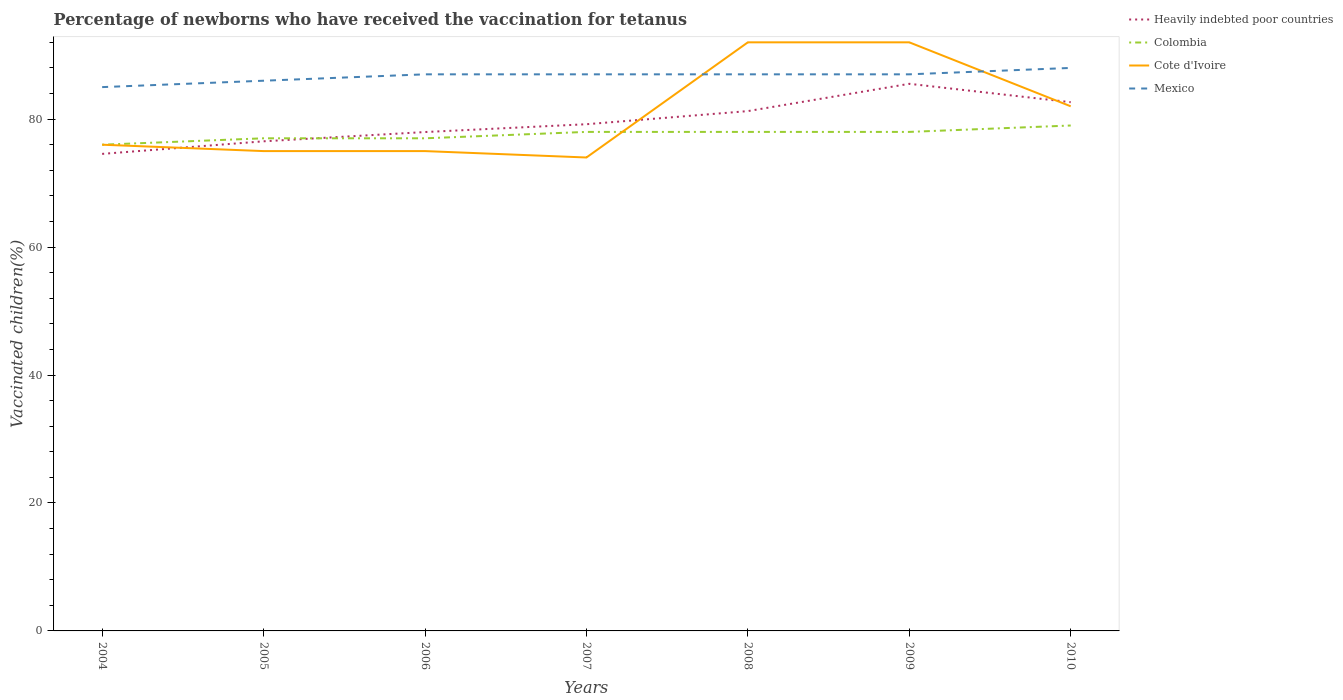How many different coloured lines are there?
Make the answer very short. 4. Across all years, what is the maximum percentage of vaccinated children in Colombia?
Your response must be concise. 76. What is the total percentage of vaccinated children in Cote d'Ivoire in the graph?
Give a very brief answer. 0. What is the difference between the highest and the second highest percentage of vaccinated children in Mexico?
Your answer should be very brief. 3. How many lines are there?
Offer a very short reply. 4. How many years are there in the graph?
Your answer should be compact. 7. Are the values on the major ticks of Y-axis written in scientific E-notation?
Your answer should be very brief. No. Does the graph contain any zero values?
Keep it short and to the point. No. Does the graph contain grids?
Give a very brief answer. No. What is the title of the graph?
Your answer should be very brief. Percentage of newborns who have received the vaccination for tetanus. What is the label or title of the Y-axis?
Offer a very short reply. Vaccinated children(%). What is the Vaccinated children(%) in Heavily indebted poor countries in 2004?
Your answer should be compact. 74.56. What is the Vaccinated children(%) of Colombia in 2004?
Your response must be concise. 76. What is the Vaccinated children(%) of Cote d'Ivoire in 2004?
Offer a terse response. 76. What is the Vaccinated children(%) of Mexico in 2004?
Give a very brief answer. 85. What is the Vaccinated children(%) in Heavily indebted poor countries in 2005?
Ensure brevity in your answer.  76.53. What is the Vaccinated children(%) of Colombia in 2005?
Offer a very short reply. 77. What is the Vaccinated children(%) in Heavily indebted poor countries in 2006?
Keep it short and to the point. 77.98. What is the Vaccinated children(%) of Colombia in 2006?
Your response must be concise. 77. What is the Vaccinated children(%) in Cote d'Ivoire in 2006?
Ensure brevity in your answer.  75. What is the Vaccinated children(%) of Mexico in 2006?
Your answer should be very brief. 87. What is the Vaccinated children(%) in Heavily indebted poor countries in 2007?
Ensure brevity in your answer.  79.2. What is the Vaccinated children(%) of Cote d'Ivoire in 2007?
Provide a short and direct response. 74. What is the Vaccinated children(%) of Heavily indebted poor countries in 2008?
Your response must be concise. 81.25. What is the Vaccinated children(%) in Cote d'Ivoire in 2008?
Your response must be concise. 92. What is the Vaccinated children(%) in Heavily indebted poor countries in 2009?
Ensure brevity in your answer.  85.52. What is the Vaccinated children(%) of Cote d'Ivoire in 2009?
Offer a terse response. 92. What is the Vaccinated children(%) of Mexico in 2009?
Your answer should be compact. 87. What is the Vaccinated children(%) in Heavily indebted poor countries in 2010?
Your answer should be compact. 82.64. What is the Vaccinated children(%) of Colombia in 2010?
Make the answer very short. 79. What is the Vaccinated children(%) of Mexico in 2010?
Your answer should be compact. 88. Across all years, what is the maximum Vaccinated children(%) in Heavily indebted poor countries?
Provide a short and direct response. 85.52. Across all years, what is the maximum Vaccinated children(%) of Colombia?
Your answer should be very brief. 79. Across all years, what is the maximum Vaccinated children(%) of Cote d'Ivoire?
Offer a very short reply. 92. Across all years, what is the minimum Vaccinated children(%) of Heavily indebted poor countries?
Provide a short and direct response. 74.56. What is the total Vaccinated children(%) in Heavily indebted poor countries in the graph?
Keep it short and to the point. 557.68. What is the total Vaccinated children(%) of Colombia in the graph?
Make the answer very short. 543. What is the total Vaccinated children(%) of Cote d'Ivoire in the graph?
Offer a very short reply. 566. What is the total Vaccinated children(%) of Mexico in the graph?
Offer a terse response. 607. What is the difference between the Vaccinated children(%) in Heavily indebted poor countries in 2004 and that in 2005?
Your response must be concise. -1.97. What is the difference between the Vaccinated children(%) in Heavily indebted poor countries in 2004 and that in 2006?
Ensure brevity in your answer.  -3.42. What is the difference between the Vaccinated children(%) of Cote d'Ivoire in 2004 and that in 2006?
Your response must be concise. 1. What is the difference between the Vaccinated children(%) of Mexico in 2004 and that in 2006?
Your answer should be compact. -2. What is the difference between the Vaccinated children(%) in Heavily indebted poor countries in 2004 and that in 2007?
Your answer should be very brief. -4.64. What is the difference between the Vaccinated children(%) of Heavily indebted poor countries in 2004 and that in 2008?
Provide a succinct answer. -6.69. What is the difference between the Vaccinated children(%) of Cote d'Ivoire in 2004 and that in 2008?
Give a very brief answer. -16. What is the difference between the Vaccinated children(%) in Mexico in 2004 and that in 2008?
Keep it short and to the point. -2. What is the difference between the Vaccinated children(%) in Heavily indebted poor countries in 2004 and that in 2009?
Offer a very short reply. -10.96. What is the difference between the Vaccinated children(%) of Cote d'Ivoire in 2004 and that in 2009?
Offer a terse response. -16. What is the difference between the Vaccinated children(%) of Mexico in 2004 and that in 2009?
Ensure brevity in your answer.  -2. What is the difference between the Vaccinated children(%) of Heavily indebted poor countries in 2004 and that in 2010?
Keep it short and to the point. -8.08. What is the difference between the Vaccinated children(%) in Heavily indebted poor countries in 2005 and that in 2006?
Your answer should be compact. -1.45. What is the difference between the Vaccinated children(%) in Cote d'Ivoire in 2005 and that in 2006?
Your response must be concise. 0. What is the difference between the Vaccinated children(%) of Heavily indebted poor countries in 2005 and that in 2007?
Provide a succinct answer. -2.67. What is the difference between the Vaccinated children(%) of Cote d'Ivoire in 2005 and that in 2007?
Keep it short and to the point. 1. What is the difference between the Vaccinated children(%) in Mexico in 2005 and that in 2007?
Provide a short and direct response. -1. What is the difference between the Vaccinated children(%) of Heavily indebted poor countries in 2005 and that in 2008?
Your response must be concise. -4.72. What is the difference between the Vaccinated children(%) of Colombia in 2005 and that in 2008?
Provide a short and direct response. -1. What is the difference between the Vaccinated children(%) in Cote d'Ivoire in 2005 and that in 2008?
Your answer should be compact. -17. What is the difference between the Vaccinated children(%) of Heavily indebted poor countries in 2005 and that in 2009?
Make the answer very short. -8.99. What is the difference between the Vaccinated children(%) in Cote d'Ivoire in 2005 and that in 2009?
Provide a short and direct response. -17. What is the difference between the Vaccinated children(%) in Mexico in 2005 and that in 2009?
Keep it short and to the point. -1. What is the difference between the Vaccinated children(%) of Heavily indebted poor countries in 2005 and that in 2010?
Ensure brevity in your answer.  -6.11. What is the difference between the Vaccinated children(%) of Cote d'Ivoire in 2005 and that in 2010?
Provide a short and direct response. -7. What is the difference between the Vaccinated children(%) of Heavily indebted poor countries in 2006 and that in 2007?
Offer a terse response. -1.22. What is the difference between the Vaccinated children(%) of Cote d'Ivoire in 2006 and that in 2007?
Give a very brief answer. 1. What is the difference between the Vaccinated children(%) in Heavily indebted poor countries in 2006 and that in 2008?
Give a very brief answer. -3.27. What is the difference between the Vaccinated children(%) in Colombia in 2006 and that in 2008?
Provide a succinct answer. -1. What is the difference between the Vaccinated children(%) in Heavily indebted poor countries in 2006 and that in 2009?
Your answer should be compact. -7.54. What is the difference between the Vaccinated children(%) of Colombia in 2006 and that in 2009?
Make the answer very short. -1. What is the difference between the Vaccinated children(%) of Cote d'Ivoire in 2006 and that in 2009?
Your answer should be compact. -17. What is the difference between the Vaccinated children(%) of Mexico in 2006 and that in 2009?
Provide a succinct answer. 0. What is the difference between the Vaccinated children(%) of Heavily indebted poor countries in 2006 and that in 2010?
Your answer should be very brief. -4.67. What is the difference between the Vaccinated children(%) in Colombia in 2006 and that in 2010?
Your response must be concise. -2. What is the difference between the Vaccinated children(%) in Cote d'Ivoire in 2006 and that in 2010?
Provide a succinct answer. -7. What is the difference between the Vaccinated children(%) in Heavily indebted poor countries in 2007 and that in 2008?
Give a very brief answer. -2.05. What is the difference between the Vaccinated children(%) in Mexico in 2007 and that in 2008?
Offer a terse response. 0. What is the difference between the Vaccinated children(%) of Heavily indebted poor countries in 2007 and that in 2009?
Offer a terse response. -6.32. What is the difference between the Vaccinated children(%) of Cote d'Ivoire in 2007 and that in 2009?
Make the answer very short. -18. What is the difference between the Vaccinated children(%) of Mexico in 2007 and that in 2009?
Give a very brief answer. 0. What is the difference between the Vaccinated children(%) in Heavily indebted poor countries in 2007 and that in 2010?
Offer a very short reply. -3.44. What is the difference between the Vaccinated children(%) in Mexico in 2007 and that in 2010?
Offer a terse response. -1. What is the difference between the Vaccinated children(%) of Heavily indebted poor countries in 2008 and that in 2009?
Offer a terse response. -4.27. What is the difference between the Vaccinated children(%) in Colombia in 2008 and that in 2009?
Your response must be concise. 0. What is the difference between the Vaccinated children(%) of Heavily indebted poor countries in 2008 and that in 2010?
Keep it short and to the point. -1.39. What is the difference between the Vaccinated children(%) in Colombia in 2008 and that in 2010?
Give a very brief answer. -1. What is the difference between the Vaccinated children(%) of Heavily indebted poor countries in 2009 and that in 2010?
Your response must be concise. 2.87. What is the difference between the Vaccinated children(%) in Cote d'Ivoire in 2009 and that in 2010?
Keep it short and to the point. 10. What is the difference between the Vaccinated children(%) of Mexico in 2009 and that in 2010?
Keep it short and to the point. -1. What is the difference between the Vaccinated children(%) in Heavily indebted poor countries in 2004 and the Vaccinated children(%) in Colombia in 2005?
Ensure brevity in your answer.  -2.44. What is the difference between the Vaccinated children(%) of Heavily indebted poor countries in 2004 and the Vaccinated children(%) of Cote d'Ivoire in 2005?
Provide a short and direct response. -0.44. What is the difference between the Vaccinated children(%) in Heavily indebted poor countries in 2004 and the Vaccinated children(%) in Mexico in 2005?
Provide a succinct answer. -11.44. What is the difference between the Vaccinated children(%) in Cote d'Ivoire in 2004 and the Vaccinated children(%) in Mexico in 2005?
Keep it short and to the point. -10. What is the difference between the Vaccinated children(%) of Heavily indebted poor countries in 2004 and the Vaccinated children(%) of Colombia in 2006?
Keep it short and to the point. -2.44. What is the difference between the Vaccinated children(%) in Heavily indebted poor countries in 2004 and the Vaccinated children(%) in Cote d'Ivoire in 2006?
Give a very brief answer. -0.44. What is the difference between the Vaccinated children(%) in Heavily indebted poor countries in 2004 and the Vaccinated children(%) in Mexico in 2006?
Your response must be concise. -12.44. What is the difference between the Vaccinated children(%) in Colombia in 2004 and the Vaccinated children(%) in Mexico in 2006?
Your response must be concise. -11. What is the difference between the Vaccinated children(%) in Cote d'Ivoire in 2004 and the Vaccinated children(%) in Mexico in 2006?
Keep it short and to the point. -11. What is the difference between the Vaccinated children(%) in Heavily indebted poor countries in 2004 and the Vaccinated children(%) in Colombia in 2007?
Your answer should be compact. -3.44. What is the difference between the Vaccinated children(%) of Heavily indebted poor countries in 2004 and the Vaccinated children(%) of Cote d'Ivoire in 2007?
Your answer should be compact. 0.56. What is the difference between the Vaccinated children(%) in Heavily indebted poor countries in 2004 and the Vaccinated children(%) in Mexico in 2007?
Your response must be concise. -12.44. What is the difference between the Vaccinated children(%) in Colombia in 2004 and the Vaccinated children(%) in Mexico in 2007?
Your response must be concise. -11. What is the difference between the Vaccinated children(%) of Heavily indebted poor countries in 2004 and the Vaccinated children(%) of Colombia in 2008?
Your answer should be compact. -3.44. What is the difference between the Vaccinated children(%) in Heavily indebted poor countries in 2004 and the Vaccinated children(%) in Cote d'Ivoire in 2008?
Offer a terse response. -17.44. What is the difference between the Vaccinated children(%) in Heavily indebted poor countries in 2004 and the Vaccinated children(%) in Mexico in 2008?
Give a very brief answer. -12.44. What is the difference between the Vaccinated children(%) of Colombia in 2004 and the Vaccinated children(%) of Cote d'Ivoire in 2008?
Keep it short and to the point. -16. What is the difference between the Vaccinated children(%) in Colombia in 2004 and the Vaccinated children(%) in Mexico in 2008?
Offer a very short reply. -11. What is the difference between the Vaccinated children(%) of Heavily indebted poor countries in 2004 and the Vaccinated children(%) of Colombia in 2009?
Offer a very short reply. -3.44. What is the difference between the Vaccinated children(%) of Heavily indebted poor countries in 2004 and the Vaccinated children(%) of Cote d'Ivoire in 2009?
Your answer should be very brief. -17.44. What is the difference between the Vaccinated children(%) in Heavily indebted poor countries in 2004 and the Vaccinated children(%) in Mexico in 2009?
Give a very brief answer. -12.44. What is the difference between the Vaccinated children(%) of Colombia in 2004 and the Vaccinated children(%) of Mexico in 2009?
Give a very brief answer. -11. What is the difference between the Vaccinated children(%) of Heavily indebted poor countries in 2004 and the Vaccinated children(%) of Colombia in 2010?
Keep it short and to the point. -4.44. What is the difference between the Vaccinated children(%) of Heavily indebted poor countries in 2004 and the Vaccinated children(%) of Cote d'Ivoire in 2010?
Your answer should be very brief. -7.44. What is the difference between the Vaccinated children(%) of Heavily indebted poor countries in 2004 and the Vaccinated children(%) of Mexico in 2010?
Your response must be concise. -13.44. What is the difference between the Vaccinated children(%) of Colombia in 2004 and the Vaccinated children(%) of Mexico in 2010?
Ensure brevity in your answer.  -12. What is the difference between the Vaccinated children(%) of Cote d'Ivoire in 2004 and the Vaccinated children(%) of Mexico in 2010?
Your answer should be very brief. -12. What is the difference between the Vaccinated children(%) of Heavily indebted poor countries in 2005 and the Vaccinated children(%) of Colombia in 2006?
Give a very brief answer. -0.47. What is the difference between the Vaccinated children(%) of Heavily indebted poor countries in 2005 and the Vaccinated children(%) of Cote d'Ivoire in 2006?
Offer a terse response. 1.53. What is the difference between the Vaccinated children(%) in Heavily indebted poor countries in 2005 and the Vaccinated children(%) in Mexico in 2006?
Ensure brevity in your answer.  -10.47. What is the difference between the Vaccinated children(%) of Colombia in 2005 and the Vaccinated children(%) of Cote d'Ivoire in 2006?
Make the answer very short. 2. What is the difference between the Vaccinated children(%) of Colombia in 2005 and the Vaccinated children(%) of Mexico in 2006?
Your response must be concise. -10. What is the difference between the Vaccinated children(%) in Heavily indebted poor countries in 2005 and the Vaccinated children(%) in Colombia in 2007?
Make the answer very short. -1.47. What is the difference between the Vaccinated children(%) of Heavily indebted poor countries in 2005 and the Vaccinated children(%) of Cote d'Ivoire in 2007?
Your answer should be very brief. 2.53. What is the difference between the Vaccinated children(%) in Heavily indebted poor countries in 2005 and the Vaccinated children(%) in Mexico in 2007?
Make the answer very short. -10.47. What is the difference between the Vaccinated children(%) of Heavily indebted poor countries in 2005 and the Vaccinated children(%) of Colombia in 2008?
Your answer should be compact. -1.47. What is the difference between the Vaccinated children(%) of Heavily indebted poor countries in 2005 and the Vaccinated children(%) of Cote d'Ivoire in 2008?
Keep it short and to the point. -15.47. What is the difference between the Vaccinated children(%) in Heavily indebted poor countries in 2005 and the Vaccinated children(%) in Mexico in 2008?
Make the answer very short. -10.47. What is the difference between the Vaccinated children(%) in Colombia in 2005 and the Vaccinated children(%) in Mexico in 2008?
Offer a terse response. -10. What is the difference between the Vaccinated children(%) in Cote d'Ivoire in 2005 and the Vaccinated children(%) in Mexico in 2008?
Provide a succinct answer. -12. What is the difference between the Vaccinated children(%) in Heavily indebted poor countries in 2005 and the Vaccinated children(%) in Colombia in 2009?
Ensure brevity in your answer.  -1.47. What is the difference between the Vaccinated children(%) in Heavily indebted poor countries in 2005 and the Vaccinated children(%) in Cote d'Ivoire in 2009?
Your answer should be compact. -15.47. What is the difference between the Vaccinated children(%) in Heavily indebted poor countries in 2005 and the Vaccinated children(%) in Mexico in 2009?
Make the answer very short. -10.47. What is the difference between the Vaccinated children(%) of Colombia in 2005 and the Vaccinated children(%) of Cote d'Ivoire in 2009?
Give a very brief answer. -15. What is the difference between the Vaccinated children(%) in Heavily indebted poor countries in 2005 and the Vaccinated children(%) in Colombia in 2010?
Provide a short and direct response. -2.47. What is the difference between the Vaccinated children(%) of Heavily indebted poor countries in 2005 and the Vaccinated children(%) of Cote d'Ivoire in 2010?
Ensure brevity in your answer.  -5.47. What is the difference between the Vaccinated children(%) of Heavily indebted poor countries in 2005 and the Vaccinated children(%) of Mexico in 2010?
Your answer should be compact. -11.47. What is the difference between the Vaccinated children(%) of Colombia in 2005 and the Vaccinated children(%) of Mexico in 2010?
Provide a succinct answer. -11. What is the difference between the Vaccinated children(%) of Cote d'Ivoire in 2005 and the Vaccinated children(%) of Mexico in 2010?
Make the answer very short. -13. What is the difference between the Vaccinated children(%) of Heavily indebted poor countries in 2006 and the Vaccinated children(%) of Colombia in 2007?
Provide a short and direct response. -0.02. What is the difference between the Vaccinated children(%) in Heavily indebted poor countries in 2006 and the Vaccinated children(%) in Cote d'Ivoire in 2007?
Your answer should be compact. 3.98. What is the difference between the Vaccinated children(%) of Heavily indebted poor countries in 2006 and the Vaccinated children(%) of Mexico in 2007?
Your answer should be very brief. -9.02. What is the difference between the Vaccinated children(%) of Cote d'Ivoire in 2006 and the Vaccinated children(%) of Mexico in 2007?
Keep it short and to the point. -12. What is the difference between the Vaccinated children(%) of Heavily indebted poor countries in 2006 and the Vaccinated children(%) of Colombia in 2008?
Keep it short and to the point. -0.02. What is the difference between the Vaccinated children(%) in Heavily indebted poor countries in 2006 and the Vaccinated children(%) in Cote d'Ivoire in 2008?
Your answer should be very brief. -14.02. What is the difference between the Vaccinated children(%) of Heavily indebted poor countries in 2006 and the Vaccinated children(%) of Mexico in 2008?
Provide a succinct answer. -9.02. What is the difference between the Vaccinated children(%) in Colombia in 2006 and the Vaccinated children(%) in Mexico in 2008?
Make the answer very short. -10. What is the difference between the Vaccinated children(%) of Cote d'Ivoire in 2006 and the Vaccinated children(%) of Mexico in 2008?
Your answer should be compact. -12. What is the difference between the Vaccinated children(%) of Heavily indebted poor countries in 2006 and the Vaccinated children(%) of Colombia in 2009?
Ensure brevity in your answer.  -0.02. What is the difference between the Vaccinated children(%) in Heavily indebted poor countries in 2006 and the Vaccinated children(%) in Cote d'Ivoire in 2009?
Your answer should be compact. -14.02. What is the difference between the Vaccinated children(%) in Heavily indebted poor countries in 2006 and the Vaccinated children(%) in Mexico in 2009?
Offer a terse response. -9.02. What is the difference between the Vaccinated children(%) in Colombia in 2006 and the Vaccinated children(%) in Mexico in 2009?
Make the answer very short. -10. What is the difference between the Vaccinated children(%) in Heavily indebted poor countries in 2006 and the Vaccinated children(%) in Colombia in 2010?
Provide a succinct answer. -1.02. What is the difference between the Vaccinated children(%) in Heavily indebted poor countries in 2006 and the Vaccinated children(%) in Cote d'Ivoire in 2010?
Make the answer very short. -4.02. What is the difference between the Vaccinated children(%) of Heavily indebted poor countries in 2006 and the Vaccinated children(%) of Mexico in 2010?
Offer a terse response. -10.02. What is the difference between the Vaccinated children(%) in Colombia in 2006 and the Vaccinated children(%) in Mexico in 2010?
Ensure brevity in your answer.  -11. What is the difference between the Vaccinated children(%) in Heavily indebted poor countries in 2007 and the Vaccinated children(%) in Colombia in 2008?
Offer a very short reply. 1.2. What is the difference between the Vaccinated children(%) in Heavily indebted poor countries in 2007 and the Vaccinated children(%) in Cote d'Ivoire in 2008?
Offer a very short reply. -12.8. What is the difference between the Vaccinated children(%) of Heavily indebted poor countries in 2007 and the Vaccinated children(%) of Mexico in 2008?
Your answer should be compact. -7.8. What is the difference between the Vaccinated children(%) in Colombia in 2007 and the Vaccinated children(%) in Cote d'Ivoire in 2008?
Provide a succinct answer. -14. What is the difference between the Vaccinated children(%) in Colombia in 2007 and the Vaccinated children(%) in Mexico in 2008?
Offer a very short reply. -9. What is the difference between the Vaccinated children(%) in Heavily indebted poor countries in 2007 and the Vaccinated children(%) in Colombia in 2009?
Offer a terse response. 1.2. What is the difference between the Vaccinated children(%) in Heavily indebted poor countries in 2007 and the Vaccinated children(%) in Cote d'Ivoire in 2009?
Provide a short and direct response. -12.8. What is the difference between the Vaccinated children(%) in Heavily indebted poor countries in 2007 and the Vaccinated children(%) in Mexico in 2009?
Your response must be concise. -7.8. What is the difference between the Vaccinated children(%) of Colombia in 2007 and the Vaccinated children(%) of Cote d'Ivoire in 2009?
Offer a terse response. -14. What is the difference between the Vaccinated children(%) of Heavily indebted poor countries in 2007 and the Vaccinated children(%) of Colombia in 2010?
Your answer should be very brief. 0.2. What is the difference between the Vaccinated children(%) of Heavily indebted poor countries in 2007 and the Vaccinated children(%) of Cote d'Ivoire in 2010?
Offer a very short reply. -2.8. What is the difference between the Vaccinated children(%) of Heavily indebted poor countries in 2007 and the Vaccinated children(%) of Mexico in 2010?
Provide a succinct answer. -8.8. What is the difference between the Vaccinated children(%) of Colombia in 2007 and the Vaccinated children(%) of Mexico in 2010?
Ensure brevity in your answer.  -10. What is the difference between the Vaccinated children(%) in Cote d'Ivoire in 2007 and the Vaccinated children(%) in Mexico in 2010?
Your response must be concise. -14. What is the difference between the Vaccinated children(%) in Heavily indebted poor countries in 2008 and the Vaccinated children(%) in Colombia in 2009?
Your answer should be very brief. 3.25. What is the difference between the Vaccinated children(%) of Heavily indebted poor countries in 2008 and the Vaccinated children(%) of Cote d'Ivoire in 2009?
Give a very brief answer. -10.75. What is the difference between the Vaccinated children(%) of Heavily indebted poor countries in 2008 and the Vaccinated children(%) of Mexico in 2009?
Provide a short and direct response. -5.75. What is the difference between the Vaccinated children(%) in Heavily indebted poor countries in 2008 and the Vaccinated children(%) in Colombia in 2010?
Keep it short and to the point. 2.25. What is the difference between the Vaccinated children(%) of Heavily indebted poor countries in 2008 and the Vaccinated children(%) of Cote d'Ivoire in 2010?
Your answer should be compact. -0.75. What is the difference between the Vaccinated children(%) of Heavily indebted poor countries in 2008 and the Vaccinated children(%) of Mexico in 2010?
Give a very brief answer. -6.75. What is the difference between the Vaccinated children(%) in Colombia in 2008 and the Vaccinated children(%) in Cote d'Ivoire in 2010?
Your response must be concise. -4. What is the difference between the Vaccinated children(%) in Colombia in 2008 and the Vaccinated children(%) in Mexico in 2010?
Your answer should be very brief. -10. What is the difference between the Vaccinated children(%) in Heavily indebted poor countries in 2009 and the Vaccinated children(%) in Colombia in 2010?
Ensure brevity in your answer.  6.52. What is the difference between the Vaccinated children(%) of Heavily indebted poor countries in 2009 and the Vaccinated children(%) of Cote d'Ivoire in 2010?
Provide a succinct answer. 3.52. What is the difference between the Vaccinated children(%) of Heavily indebted poor countries in 2009 and the Vaccinated children(%) of Mexico in 2010?
Provide a succinct answer. -2.48. What is the difference between the Vaccinated children(%) of Colombia in 2009 and the Vaccinated children(%) of Cote d'Ivoire in 2010?
Your response must be concise. -4. What is the average Vaccinated children(%) of Heavily indebted poor countries per year?
Provide a short and direct response. 79.67. What is the average Vaccinated children(%) of Colombia per year?
Your response must be concise. 77.57. What is the average Vaccinated children(%) in Cote d'Ivoire per year?
Make the answer very short. 80.86. What is the average Vaccinated children(%) in Mexico per year?
Offer a very short reply. 86.71. In the year 2004, what is the difference between the Vaccinated children(%) of Heavily indebted poor countries and Vaccinated children(%) of Colombia?
Keep it short and to the point. -1.44. In the year 2004, what is the difference between the Vaccinated children(%) of Heavily indebted poor countries and Vaccinated children(%) of Cote d'Ivoire?
Your answer should be very brief. -1.44. In the year 2004, what is the difference between the Vaccinated children(%) of Heavily indebted poor countries and Vaccinated children(%) of Mexico?
Provide a succinct answer. -10.44. In the year 2004, what is the difference between the Vaccinated children(%) of Cote d'Ivoire and Vaccinated children(%) of Mexico?
Provide a short and direct response. -9. In the year 2005, what is the difference between the Vaccinated children(%) of Heavily indebted poor countries and Vaccinated children(%) of Colombia?
Your answer should be very brief. -0.47. In the year 2005, what is the difference between the Vaccinated children(%) of Heavily indebted poor countries and Vaccinated children(%) of Cote d'Ivoire?
Your answer should be compact. 1.53. In the year 2005, what is the difference between the Vaccinated children(%) in Heavily indebted poor countries and Vaccinated children(%) in Mexico?
Make the answer very short. -9.47. In the year 2005, what is the difference between the Vaccinated children(%) of Cote d'Ivoire and Vaccinated children(%) of Mexico?
Give a very brief answer. -11. In the year 2006, what is the difference between the Vaccinated children(%) in Heavily indebted poor countries and Vaccinated children(%) in Colombia?
Offer a very short reply. 0.98. In the year 2006, what is the difference between the Vaccinated children(%) of Heavily indebted poor countries and Vaccinated children(%) of Cote d'Ivoire?
Ensure brevity in your answer.  2.98. In the year 2006, what is the difference between the Vaccinated children(%) in Heavily indebted poor countries and Vaccinated children(%) in Mexico?
Provide a succinct answer. -9.02. In the year 2006, what is the difference between the Vaccinated children(%) of Colombia and Vaccinated children(%) of Cote d'Ivoire?
Your response must be concise. 2. In the year 2006, what is the difference between the Vaccinated children(%) of Cote d'Ivoire and Vaccinated children(%) of Mexico?
Offer a terse response. -12. In the year 2007, what is the difference between the Vaccinated children(%) of Heavily indebted poor countries and Vaccinated children(%) of Colombia?
Offer a very short reply. 1.2. In the year 2007, what is the difference between the Vaccinated children(%) in Heavily indebted poor countries and Vaccinated children(%) in Cote d'Ivoire?
Your response must be concise. 5.2. In the year 2007, what is the difference between the Vaccinated children(%) in Heavily indebted poor countries and Vaccinated children(%) in Mexico?
Your answer should be very brief. -7.8. In the year 2007, what is the difference between the Vaccinated children(%) in Colombia and Vaccinated children(%) in Cote d'Ivoire?
Provide a succinct answer. 4. In the year 2008, what is the difference between the Vaccinated children(%) of Heavily indebted poor countries and Vaccinated children(%) of Colombia?
Your response must be concise. 3.25. In the year 2008, what is the difference between the Vaccinated children(%) in Heavily indebted poor countries and Vaccinated children(%) in Cote d'Ivoire?
Your answer should be very brief. -10.75. In the year 2008, what is the difference between the Vaccinated children(%) of Heavily indebted poor countries and Vaccinated children(%) of Mexico?
Provide a succinct answer. -5.75. In the year 2009, what is the difference between the Vaccinated children(%) of Heavily indebted poor countries and Vaccinated children(%) of Colombia?
Offer a terse response. 7.52. In the year 2009, what is the difference between the Vaccinated children(%) of Heavily indebted poor countries and Vaccinated children(%) of Cote d'Ivoire?
Your answer should be very brief. -6.48. In the year 2009, what is the difference between the Vaccinated children(%) of Heavily indebted poor countries and Vaccinated children(%) of Mexico?
Offer a very short reply. -1.48. In the year 2009, what is the difference between the Vaccinated children(%) of Colombia and Vaccinated children(%) of Cote d'Ivoire?
Provide a short and direct response. -14. In the year 2009, what is the difference between the Vaccinated children(%) of Colombia and Vaccinated children(%) of Mexico?
Ensure brevity in your answer.  -9. In the year 2009, what is the difference between the Vaccinated children(%) of Cote d'Ivoire and Vaccinated children(%) of Mexico?
Ensure brevity in your answer.  5. In the year 2010, what is the difference between the Vaccinated children(%) of Heavily indebted poor countries and Vaccinated children(%) of Colombia?
Your response must be concise. 3.64. In the year 2010, what is the difference between the Vaccinated children(%) of Heavily indebted poor countries and Vaccinated children(%) of Cote d'Ivoire?
Provide a short and direct response. 0.64. In the year 2010, what is the difference between the Vaccinated children(%) of Heavily indebted poor countries and Vaccinated children(%) of Mexico?
Ensure brevity in your answer.  -5.36. In the year 2010, what is the difference between the Vaccinated children(%) of Cote d'Ivoire and Vaccinated children(%) of Mexico?
Your answer should be compact. -6. What is the ratio of the Vaccinated children(%) of Heavily indebted poor countries in 2004 to that in 2005?
Ensure brevity in your answer.  0.97. What is the ratio of the Vaccinated children(%) of Cote d'Ivoire in 2004 to that in 2005?
Offer a terse response. 1.01. What is the ratio of the Vaccinated children(%) in Mexico in 2004 to that in 2005?
Your answer should be compact. 0.99. What is the ratio of the Vaccinated children(%) of Heavily indebted poor countries in 2004 to that in 2006?
Your answer should be very brief. 0.96. What is the ratio of the Vaccinated children(%) of Colombia in 2004 to that in 2006?
Give a very brief answer. 0.99. What is the ratio of the Vaccinated children(%) in Cote d'Ivoire in 2004 to that in 2006?
Provide a succinct answer. 1.01. What is the ratio of the Vaccinated children(%) of Mexico in 2004 to that in 2006?
Your answer should be very brief. 0.98. What is the ratio of the Vaccinated children(%) in Heavily indebted poor countries in 2004 to that in 2007?
Give a very brief answer. 0.94. What is the ratio of the Vaccinated children(%) in Colombia in 2004 to that in 2007?
Provide a succinct answer. 0.97. What is the ratio of the Vaccinated children(%) in Cote d'Ivoire in 2004 to that in 2007?
Make the answer very short. 1.03. What is the ratio of the Vaccinated children(%) in Heavily indebted poor countries in 2004 to that in 2008?
Offer a very short reply. 0.92. What is the ratio of the Vaccinated children(%) in Colombia in 2004 to that in 2008?
Your answer should be very brief. 0.97. What is the ratio of the Vaccinated children(%) of Cote d'Ivoire in 2004 to that in 2008?
Keep it short and to the point. 0.83. What is the ratio of the Vaccinated children(%) of Mexico in 2004 to that in 2008?
Your response must be concise. 0.98. What is the ratio of the Vaccinated children(%) in Heavily indebted poor countries in 2004 to that in 2009?
Provide a short and direct response. 0.87. What is the ratio of the Vaccinated children(%) of Colombia in 2004 to that in 2009?
Offer a terse response. 0.97. What is the ratio of the Vaccinated children(%) of Cote d'Ivoire in 2004 to that in 2009?
Your answer should be compact. 0.83. What is the ratio of the Vaccinated children(%) in Mexico in 2004 to that in 2009?
Make the answer very short. 0.98. What is the ratio of the Vaccinated children(%) in Heavily indebted poor countries in 2004 to that in 2010?
Offer a very short reply. 0.9. What is the ratio of the Vaccinated children(%) in Colombia in 2004 to that in 2010?
Your answer should be very brief. 0.96. What is the ratio of the Vaccinated children(%) in Cote d'Ivoire in 2004 to that in 2010?
Provide a succinct answer. 0.93. What is the ratio of the Vaccinated children(%) of Mexico in 2004 to that in 2010?
Keep it short and to the point. 0.97. What is the ratio of the Vaccinated children(%) of Heavily indebted poor countries in 2005 to that in 2006?
Your answer should be compact. 0.98. What is the ratio of the Vaccinated children(%) of Colombia in 2005 to that in 2006?
Offer a terse response. 1. What is the ratio of the Vaccinated children(%) of Cote d'Ivoire in 2005 to that in 2006?
Make the answer very short. 1. What is the ratio of the Vaccinated children(%) in Mexico in 2005 to that in 2006?
Provide a short and direct response. 0.99. What is the ratio of the Vaccinated children(%) in Heavily indebted poor countries in 2005 to that in 2007?
Provide a short and direct response. 0.97. What is the ratio of the Vaccinated children(%) of Colombia in 2005 to that in 2007?
Give a very brief answer. 0.99. What is the ratio of the Vaccinated children(%) in Cote d'Ivoire in 2005 to that in 2007?
Your answer should be very brief. 1.01. What is the ratio of the Vaccinated children(%) in Mexico in 2005 to that in 2007?
Make the answer very short. 0.99. What is the ratio of the Vaccinated children(%) in Heavily indebted poor countries in 2005 to that in 2008?
Provide a succinct answer. 0.94. What is the ratio of the Vaccinated children(%) of Colombia in 2005 to that in 2008?
Your answer should be compact. 0.99. What is the ratio of the Vaccinated children(%) of Cote d'Ivoire in 2005 to that in 2008?
Provide a succinct answer. 0.82. What is the ratio of the Vaccinated children(%) in Heavily indebted poor countries in 2005 to that in 2009?
Your answer should be very brief. 0.89. What is the ratio of the Vaccinated children(%) of Colombia in 2005 to that in 2009?
Ensure brevity in your answer.  0.99. What is the ratio of the Vaccinated children(%) in Cote d'Ivoire in 2005 to that in 2009?
Your answer should be compact. 0.82. What is the ratio of the Vaccinated children(%) of Mexico in 2005 to that in 2009?
Keep it short and to the point. 0.99. What is the ratio of the Vaccinated children(%) of Heavily indebted poor countries in 2005 to that in 2010?
Offer a very short reply. 0.93. What is the ratio of the Vaccinated children(%) in Colombia in 2005 to that in 2010?
Offer a very short reply. 0.97. What is the ratio of the Vaccinated children(%) of Cote d'Ivoire in 2005 to that in 2010?
Your response must be concise. 0.91. What is the ratio of the Vaccinated children(%) of Mexico in 2005 to that in 2010?
Your response must be concise. 0.98. What is the ratio of the Vaccinated children(%) of Heavily indebted poor countries in 2006 to that in 2007?
Give a very brief answer. 0.98. What is the ratio of the Vaccinated children(%) in Colombia in 2006 to that in 2007?
Offer a very short reply. 0.99. What is the ratio of the Vaccinated children(%) of Cote d'Ivoire in 2006 to that in 2007?
Provide a succinct answer. 1.01. What is the ratio of the Vaccinated children(%) in Mexico in 2006 to that in 2007?
Your answer should be compact. 1. What is the ratio of the Vaccinated children(%) of Heavily indebted poor countries in 2006 to that in 2008?
Your answer should be compact. 0.96. What is the ratio of the Vaccinated children(%) in Colombia in 2006 to that in 2008?
Offer a very short reply. 0.99. What is the ratio of the Vaccinated children(%) in Cote d'Ivoire in 2006 to that in 2008?
Your answer should be compact. 0.82. What is the ratio of the Vaccinated children(%) of Heavily indebted poor countries in 2006 to that in 2009?
Offer a terse response. 0.91. What is the ratio of the Vaccinated children(%) in Colombia in 2006 to that in 2009?
Provide a succinct answer. 0.99. What is the ratio of the Vaccinated children(%) of Cote d'Ivoire in 2006 to that in 2009?
Your answer should be very brief. 0.82. What is the ratio of the Vaccinated children(%) in Mexico in 2006 to that in 2009?
Your response must be concise. 1. What is the ratio of the Vaccinated children(%) in Heavily indebted poor countries in 2006 to that in 2010?
Ensure brevity in your answer.  0.94. What is the ratio of the Vaccinated children(%) of Colombia in 2006 to that in 2010?
Provide a short and direct response. 0.97. What is the ratio of the Vaccinated children(%) in Cote d'Ivoire in 2006 to that in 2010?
Your response must be concise. 0.91. What is the ratio of the Vaccinated children(%) in Mexico in 2006 to that in 2010?
Offer a terse response. 0.99. What is the ratio of the Vaccinated children(%) of Heavily indebted poor countries in 2007 to that in 2008?
Your answer should be compact. 0.97. What is the ratio of the Vaccinated children(%) of Colombia in 2007 to that in 2008?
Give a very brief answer. 1. What is the ratio of the Vaccinated children(%) in Cote d'Ivoire in 2007 to that in 2008?
Your answer should be very brief. 0.8. What is the ratio of the Vaccinated children(%) in Heavily indebted poor countries in 2007 to that in 2009?
Your response must be concise. 0.93. What is the ratio of the Vaccinated children(%) of Cote d'Ivoire in 2007 to that in 2009?
Make the answer very short. 0.8. What is the ratio of the Vaccinated children(%) of Heavily indebted poor countries in 2007 to that in 2010?
Your answer should be very brief. 0.96. What is the ratio of the Vaccinated children(%) in Colombia in 2007 to that in 2010?
Your response must be concise. 0.99. What is the ratio of the Vaccinated children(%) in Cote d'Ivoire in 2007 to that in 2010?
Your answer should be very brief. 0.9. What is the ratio of the Vaccinated children(%) of Mexico in 2007 to that in 2010?
Offer a very short reply. 0.99. What is the ratio of the Vaccinated children(%) of Heavily indebted poor countries in 2008 to that in 2009?
Make the answer very short. 0.95. What is the ratio of the Vaccinated children(%) in Colombia in 2008 to that in 2009?
Provide a succinct answer. 1. What is the ratio of the Vaccinated children(%) in Cote d'Ivoire in 2008 to that in 2009?
Provide a succinct answer. 1. What is the ratio of the Vaccinated children(%) of Heavily indebted poor countries in 2008 to that in 2010?
Your answer should be very brief. 0.98. What is the ratio of the Vaccinated children(%) of Colombia in 2008 to that in 2010?
Make the answer very short. 0.99. What is the ratio of the Vaccinated children(%) of Cote d'Ivoire in 2008 to that in 2010?
Offer a very short reply. 1.12. What is the ratio of the Vaccinated children(%) of Heavily indebted poor countries in 2009 to that in 2010?
Provide a succinct answer. 1.03. What is the ratio of the Vaccinated children(%) in Colombia in 2009 to that in 2010?
Give a very brief answer. 0.99. What is the ratio of the Vaccinated children(%) of Cote d'Ivoire in 2009 to that in 2010?
Your answer should be compact. 1.12. What is the difference between the highest and the second highest Vaccinated children(%) of Heavily indebted poor countries?
Provide a succinct answer. 2.87. What is the difference between the highest and the second highest Vaccinated children(%) of Cote d'Ivoire?
Make the answer very short. 0. What is the difference between the highest and the second highest Vaccinated children(%) of Mexico?
Make the answer very short. 1. What is the difference between the highest and the lowest Vaccinated children(%) in Heavily indebted poor countries?
Keep it short and to the point. 10.96. What is the difference between the highest and the lowest Vaccinated children(%) of Mexico?
Your answer should be very brief. 3. 